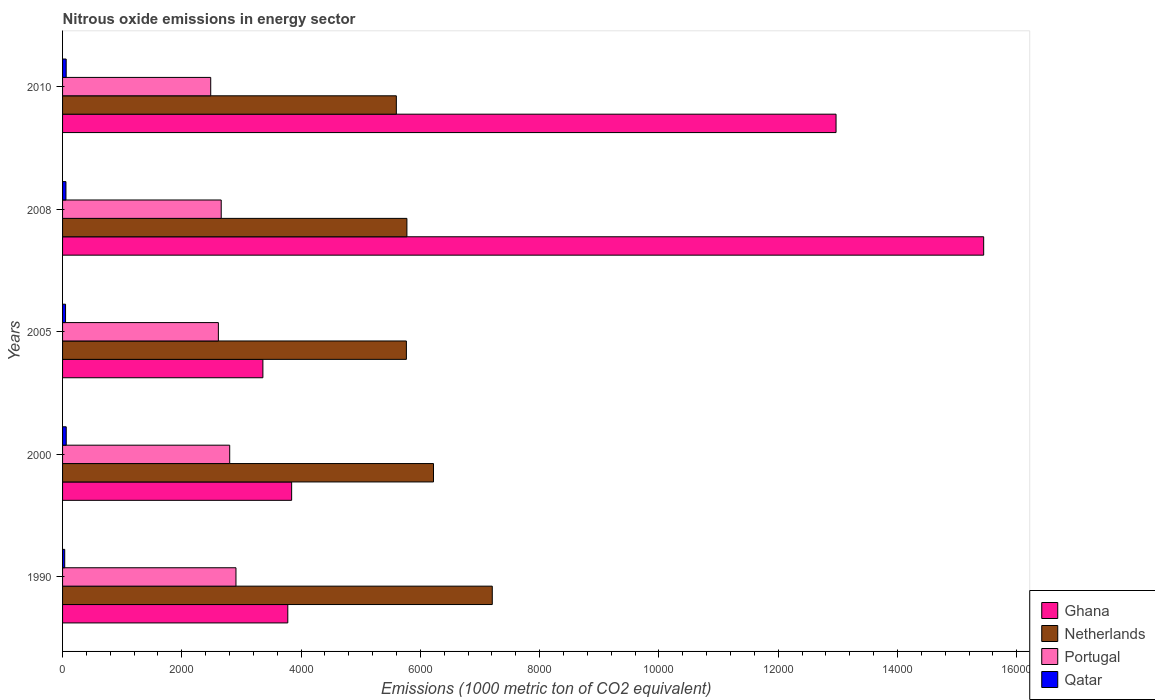How many groups of bars are there?
Make the answer very short. 5. Are the number of bars per tick equal to the number of legend labels?
Offer a very short reply. Yes. Are the number of bars on each tick of the Y-axis equal?
Provide a succinct answer. Yes. How many bars are there on the 2nd tick from the top?
Give a very brief answer. 4. What is the label of the 3rd group of bars from the top?
Make the answer very short. 2005. In how many cases, is the number of bars for a given year not equal to the number of legend labels?
Offer a terse response. 0. What is the amount of nitrous oxide emitted in Netherlands in 2005?
Ensure brevity in your answer.  5764.8. Across all years, what is the maximum amount of nitrous oxide emitted in Qatar?
Make the answer very short. 61.6. Across all years, what is the minimum amount of nitrous oxide emitted in Netherlands?
Provide a succinct answer. 5596.3. What is the total amount of nitrous oxide emitted in Portugal in the graph?
Give a very brief answer. 1.35e+04. What is the difference between the amount of nitrous oxide emitted in Qatar in 1990 and that in 2008?
Offer a terse response. -20.6. What is the difference between the amount of nitrous oxide emitted in Ghana in 2010 and the amount of nitrous oxide emitted in Netherlands in 2008?
Offer a very short reply. 7195.3. What is the average amount of nitrous oxide emitted in Netherlands per year?
Offer a terse response. 6111.84. In the year 2008, what is the difference between the amount of nitrous oxide emitted in Netherlands and amount of nitrous oxide emitted in Qatar?
Keep it short and to the point. 5717. What is the ratio of the amount of nitrous oxide emitted in Ghana in 2000 to that in 2008?
Ensure brevity in your answer.  0.25. Is the amount of nitrous oxide emitted in Ghana in 1990 less than that in 2005?
Ensure brevity in your answer.  No. Is the difference between the amount of nitrous oxide emitted in Netherlands in 1990 and 2010 greater than the difference between the amount of nitrous oxide emitted in Qatar in 1990 and 2010?
Your answer should be compact. Yes. What is the difference between the highest and the second highest amount of nitrous oxide emitted in Netherlands?
Your response must be concise. 985.5. What is the difference between the highest and the lowest amount of nitrous oxide emitted in Qatar?
Offer a terse response. 25.6. In how many years, is the amount of nitrous oxide emitted in Ghana greater than the average amount of nitrous oxide emitted in Ghana taken over all years?
Your response must be concise. 2. Is the sum of the amount of nitrous oxide emitted in Ghana in 1990 and 2005 greater than the maximum amount of nitrous oxide emitted in Portugal across all years?
Make the answer very short. Yes. Is it the case that in every year, the sum of the amount of nitrous oxide emitted in Netherlands and amount of nitrous oxide emitted in Qatar is greater than the sum of amount of nitrous oxide emitted in Ghana and amount of nitrous oxide emitted in Portugal?
Provide a short and direct response. Yes. What does the 4th bar from the top in 1990 represents?
Provide a succinct answer. Ghana. Are all the bars in the graph horizontal?
Give a very brief answer. Yes. What is the difference between two consecutive major ticks on the X-axis?
Provide a succinct answer. 2000. Are the values on the major ticks of X-axis written in scientific E-notation?
Keep it short and to the point. No. Does the graph contain any zero values?
Provide a short and direct response. No. How are the legend labels stacked?
Give a very brief answer. Vertical. What is the title of the graph?
Your answer should be very brief. Nitrous oxide emissions in energy sector. Does "Seychelles" appear as one of the legend labels in the graph?
Your answer should be compact. No. What is the label or title of the X-axis?
Your response must be concise. Emissions (1000 metric ton of CO2 equivalent). What is the label or title of the Y-axis?
Offer a very short reply. Years. What is the Emissions (1000 metric ton of CO2 equivalent) of Ghana in 1990?
Offer a very short reply. 3776.4. What is the Emissions (1000 metric ton of CO2 equivalent) of Netherlands in 1990?
Offer a very short reply. 7205. What is the Emissions (1000 metric ton of CO2 equivalent) of Portugal in 1990?
Offer a terse response. 2907.5. What is the Emissions (1000 metric ton of CO2 equivalent) in Qatar in 1990?
Ensure brevity in your answer.  36. What is the Emissions (1000 metric ton of CO2 equivalent) of Ghana in 2000?
Your answer should be compact. 3840.8. What is the Emissions (1000 metric ton of CO2 equivalent) of Netherlands in 2000?
Provide a short and direct response. 6219.5. What is the Emissions (1000 metric ton of CO2 equivalent) in Portugal in 2000?
Provide a succinct answer. 2802.4. What is the Emissions (1000 metric ton of CO2 equivalent) in Qatar in 2000?
Your answer should be compact. 61.6. What is the Emissions (1000 metric ton of CO2 equivalent) of Ghana in 2005?
Your answer should be very brief. 3358.7. What is the Emissions (1000 metric ton of CO2 equivalent) of Netherlands in 2005?
Offer a terse response. 5764.8. What is the Emissions (1000 metric ton of CO2 equivalent) of Portugal in 2005?
Provide a short and direct response. 2612.4. What is the Emissions (1000 metric ton of CO2 equivalent) in Qatar in 2005?
Make the answer very short. 49.9. What is the Emissions (1000 metric ton of CO2 equivalent) in Ghana in 2008?
Offer a terse response. 1.54e+04. What is the Emissions (1000 metric ton of CO2 equivalent) in Netherlands in 2008?
Your answer should be very brief. 5773.6. What is the Emissions (1000 metric ton of CO2 equivalent) in Portugal in 2008?
Offer a very short reply. 2660.2. What is the Emissions (1000 metric ton of CO2 equivalent) of Qatar in 2008?
Make the answer very short. 56.6. What is the Emissions (1000 metric ton of CO2 equivalent) of Ghana in 2010?
Your response must be concise. 1.30e+04. What is the Emissions (1000 metric ton of CO2 equivalent) of Netherlands in 2010?
Make the answer very short. 5596.3. What is the Emissions (1000 metric ton of CO2 equivalent) in Portugal in 2010?
Provide a succinct answer. 2484. What is the Emissions (1000 metric ton of CO2 equivalent) of Qatar in 2010?
Your answer should be very brief. 60.6. Across all years, what is the maximum Emissions (1000 metric ton of CO2 equivalent) of Ghana?
Your answer should be very brief. 1.54e+04. Across all years, what is the maximum Emissions (1000 metric ton of CO2 equivalent) of Netherlands?
Offer a terse response. 7205. Across all years, what is the maximum Emissions (1000 metric ton of CO2 equivalent) of Portugal?
Give a very brief answer. 2907.5. Across all years, what is the maximum Emissions (1000 metric ton of CO2 equivalent) in Qatar?
Your response must be concise. 61.6. Across all years, what is the minimum Emissions (1000 metric ton of CO2 equivalent) in Ghana?
Offer a very short reply. 3358.7. Across all years, what is the minimum Emissions (1000 metric ton of CO2 equivalent) of Netherlands?
Provide a short and direct response. 5596.3. Across all years, what is the minimum Emissions (1000 metric ton of CO2 equivalent) of Portugal?
Offer a very short reply. 2484. What is the total Emissions (1000 metric ton of CO2 equivalent) of Ghana in the graph?
Provide a short and direct response. 3.94e+04. What is the total Emissions (1000 metric ton of CO2 equivalent) in Netherlands in the graph?
Give a very brief answer. 3.06e+04. What is the total Emissions (1000 metric ton of CO2 equivalent) of Portugal in the graph?
Ensure brevity in your answer.  1.35e+04. What is the total Emissions (1000 metric ton of CO2 equivalent) in Qatar in the graph?
Ensure brevity in your answer.  264.7. What is the difference between the Emissions (1000 metric ton of CO2 equivalent) of Ghana in 1990 and that in 2000?
Offer a very short reply. -64.4. What is the difference between the Emissions (1000 metric ton of CO2 equivalent) of Netherlands in 1990 and that in 2000?
Your answer should be compact. 985.5. What is the difference between the Emissions (1000 metric ton of CO2 equivalent) in Portugal in 1990 and that in 2000?
Your answer should be compact. 105.1. What is the difference between the Emissions (1000 metric ton of CO2 equivalent) of Qatar in 1990 and that in 2000?
Your answer should be very brief. -25.6. What is the difference between the Emissions (1000 metric ton of CO2 equivalent) of Ghana in 1990 and that in 2005?
Provide a succinct answer. 417.7. What is the difference between the Emissions (1000 metric ton of CO2 equivalent) of Netherlands in 1990 and that in 2005?
Ensure brevity in your answer.  1440.2. What is the difference between the Emissions (1000 metric ton of CO2 equivalent) in Portugal in 1990 and that in 2005?
Offer a terse response. 295.1. What is the difference between the Emissions (1000 metric ton of CO2 equivalent) in Qatar in 1990 and that in 2005?
Provide a succinct answer. -13.9. What is the difference between the Emissions (1000 metric ton of CO2 equivalent) of Ghana in 1990 and that in 2008?
Offer a very short reply. -1.17e+04. What is the difference between the Emissions (1000 metric ton of CO2 equivalent) of Netherlands in 1990 and that in 2008?
Provide a short and direct response. 1431.4. What is the difference between the Emissions (1000 metric ton of CO2 equivalent) in Portugal in 1990 and that in 2008?
Keep it short and to the point. 247.3. What is the difference between the Emissions (1000 metric ton of CO2 equivalent) in Qatar in 1990 and that in 2008?
Provide a short and direct response. -20.6. What is the difference between the Emissions (1000 metric ton of CO2 equivalent) in Ghana in 1990 and that in 2010?
Give a very brief answer. -9192.5. What is the difference between the Emissions (1000 metric ton of CO2 equivalent) of Netherlands in 1990 and that in 2010?
Provide a succinct answer. 1608.7. What is the difference between the Emissions (1000 metric ton of CO2 equivalent) of Portugal in 1990 and that in 2010?
Provide a succinct answer. 423.5. What is the difference between the Emissions (1000 metric ton of CO2 equivalent) in Qatar in 1990 and that in 2010?
Your response must be concise. -24.6. What is the difference between the Emissions (1000 metric ton of CO2 equivalent) in Ghana in 2000 and that in 2005?
Your response must be concise. 482.1. What is the difference between the Emissions (1000 metric ton of CO2 equivalent) in Netherlands in 2000 and that in 2005?
Make the answer very short. 454.7. What is the difference between the Emissions (1000 metric ton of CO2 equivalent) in Portugal in 2000 and that in 2005?
Give a very brief answer. 190. What is the difference between the Emissions (1000 metric ton of CO2 equivalent) in Ghana in 2000 and that in 2008?
Give a very brief answer. -1.16e+04. What is the difference between the Emissions (1000 metric ton of CO2 equivalent) in Netherlands in 2000 and that in 2008?
Ensure brevity in your answer.  445.9. What is the difference between the Emissions (1000 metric ton of CO2 equivalent) in Portugal in 2000 and that in 2008?
Make the answer very short. 142.2. What is the difference between the Emissions (1000 metric ton of CO2 equivalent) in Qatar in 2000 and that in 2008?
Give a very brief answer. 5. What is the difference between the Emissions (1000 metric ton of CO2 equivalent) of Ghana in 2000 and that in 2010?
Offer a terse response. -9128.1. What is the difference between the Emissions (1000 metric ton of CO2 equivalent) in Netherlands in 2000 and that in 2010?
Your answer should be very brief. 623.2. What is the difference between the Emissions (1000 metric ton of CO2 equivalent) of Portugal in 2000 and that in 2010?
Your response must be concise. 318.4. What is the difference between the Emissions (1000 metric ton of CO2 equivalent) of Qatar in 2000 and that in 2010?
Provide a short and direct response. 1. What is the difference between the Emissions (1000 metric ton of CO2 equivalent) in Ghana in 2005 and that in 2008?
Keep it short and to the point. -1.21e+04. What is the difference between the Emissions (1000 metric ton of CO2 equivalent) in Portugal in 2005 and that in 2008?
Give a very brief answer. -47.8. What is the difference between the Emissions (1000 metric ton of CO2 equivalent) in Ghana in 2005 and that in 2010?
Your answer should be compact. -9610.2. What is the difference between the Emissions (1000 metric ton of CO2 equivalent) of Netherlands in 2005 and that in 2010?
Provide a succinct answer. 168.5. What is the difference between the Emissions (1000 metric ton of CO2 equivalent) in Portugal in 2005 and that in 2010?
Give a very brief answer. 128.4. What is the difference between the Emissions (1000 metric ton of CO2 equivalent) in Ghana in 2008 and that in 2010?
Ensure brevity in your answer.  2475.2. What is the difference between the Emissions (1000 metric ton of CO2 equivalent) of Netherlands in 2008 and that in 2010?
Your answer should be compact. 177.3. What is the difference between the Emissions (1000 metric ton of CO2 equivalent) in Portugal in 2008 and that in 2010?
Offer a terse response. 176.2. What is the difference between the Emissions (1000 metric ton of CO2 equivalent) in Qatar in 2008 and that in 2010?
Offer a very short reply. -4. What is the difference between the Emissions (1000 metric ton of CO2 equivalent) in Ghana in 1990 and the Emissions (1000 metric ton of CO2 equivalent) in Netherlands in 2000?
Offer a very short reply. -2443.1. What is the difference between the Emissions (1000 metric ton of CO2 equivalent) of Ghana in 1990 and the Emissions (1000 metric ton of CO2 equivalent) of Portugal in 2000?
Your answer should be compact. 974. What is the difference between the Emissions (1000 metric ton of CO2 equivalent) of Ghana in 1990 and the Emissions (1000 metric ton of CO2 equivalent) of Qatar in 2000?
Provide a short and direct response. 3714.8. What is the difference between the Emissions (1000 metric ton of CO2 equivalent) in Netherlands in 1990 and the Emissions (1000 metric ton of CO2 equivalent) in Portugal in 2000?
Your answer should be very brief. 4402.6. What is the difference between the Emissions (1000 metric ton of CO2 equivalent) in Netherlands in 1990 and the Emissions (1000 metric ton of CO2 equivalent) in Qatar in 2000?
Make the answer very short. 7143.4. What is the difference between the Emissions (1000 metric ton of CO2 equivalent) in Portugal in 1990 and the Emissions (1000 metric ton of CO2 equivalent) in Qatar in 2000?
Make the answer very short. 2845.9. What is the difference between the Emissions (1000 metric ton of CO2 equivalent) in Ghana in 1990 and the Emissions (1000 metric ton of CO2 equivalent) in Netherlands in 2005?
Provide a succinct answer. -1988.4. What is the difference between the Emissions (1000 metric ton of CO2 equivalent) of Ghana in 1990 and the Emissions (1000 metric ton of CO2 equivalent) of Portugal in 2005?
Your answer should be compact. 1164. What is the difference between the Emissions (1000 metric ton of CO2 equivalent) in Ghana in 1990 and the Emissions (1000 metric ton of CO2 equivalent) in Qatar in 2005?
Make the answer very short. 3726.5. What is the difference between the Emissions (1000 metric ton of CO2 equivalent) of Netherlands in 1990 and the Emissions (1000 metric ton of CO2 equivalent) of Portugal in 2005?
Your response must be concise. 4592.6. What is the difference between the Emissions (1000 metric ton of CO2 equivalent) of Netherlands in 1990 and the Emissions (1000 metric ton of CO2 equivalent) of Qatar in 2005?
Offer a very short reply. 7155.1. What is the difference between the Emissions (1000 metric ton of CO2 equivalent) of Portugal in 1990 and the Emissions (1000 metric ton of CO2 equivalent) of Qatar in 2005?
Offer a very short reply. 2857.6. What is the difference between the Emissions (1000 metric ton of CO2 equivalent) in Ghana in 1990 and the Emissions (1000 metric ton of CO2 equivalent) in Netherlands in 2008?
Ensure brevity in your answer.  -1997.2. What is the difference between the Emissions (1000 metric ton of CO2 equivalent) in Ghana in 1990 and the Emissions (1000 metric ton of CO2 equivalent) in Portugal in 2008?
Your response must be concise. 1116.2. What is the difference between the Emissions (1000 metric ton of CO2 equivalent) of Ghana in 1990 and the Emissions (1000 metric ton of CO2 equivalent) of Qatar in 2008?
Your response must be concise. 3719.8. What is the difference between the Emissions (1000 metric ton of CO2 equivalent) in Netherlands in 1990 and the Emissions (1000 metric ton of CO2 equivalent) in Portugal in 2008?
Give a very brief answer. 4544.8. What is the difference between the Emissions (1000 metric ton of CO2 equivalent) in Netherlands in 1990 and the Emissions (1000 metric ton of CO2 equivalent) in Qatar in 2008?
Provide a short and direct response. 7148.4. What is the difference between the Emissions (1000 metric ton of CO2 equivalent) of Portugal in 1990 and the Emissions (1000 metric ton of CO2 equivalent) of Qatar in 2008?
Provide a short and direct response. 2850.9. What is the difference between the Emissions (1000 metric ton of CO2 equivalent) of Ghana in 1990 and the Emissions (1000 metric ton of CO2 equivalent) of Netherlands in 2010?
Your answer should be compact. -1819.9. What is the difference between the Emissions (1000 metric ton of CO2 equivalent) in Ghana in 1990 and the Emissions (1000 metric ton of CO2 equivalent) in Portugal in 2010?
Give a very brief answer. 1292.4. What is the difference between the Emissions (1000 metric ton of CO2 equivalent) in Ghana in 1990 and the Emissions (1000 metric ton of CO2 equivalent) in Qatar in 2010?
Offer a terse response. 3715.8. What is the difference between the Emissions (1000 metric ton of CO2 equivalent) in Netherlands in 1990 and the Emissions (1000 metric ton of CO2 equivalent) in Portugal in 2010?
Ensure brevity in your answer.  4721. What is the difference between the Emissions (1000 metric ton of CO2 equivalent) in Netherlands in 1990 and the Emissions (1000 metric ton of CO2 equivalent) in Qatar in 2010?
Offer a terse response. 7144.4. What is the difference between the Emissions (1000 metric ton of CO2 equivalent) of Portugal in 1990 and the Emissions (1000 metric ton of CO2 equivalent) of Qatar in 2010?
Provide a succinct answer. 2846.9. What is the difference between the Emissions (1000 metric ton of CO2 equivalent) of Ghana in 2000 and the Emissions (1000 metric ton of CO2 equivalent) of Netherlands in 2005?
Provide a succinct answer. -1924. What is the difference between the Emissions (1000 metric ton of CO2 equivalent) in Ghana in 2000 and the Emissions (1000 metric ton of CO2 equivalent) in Portugal in 2005?
Give a very brief answer. 1228.4. What is the difference between the Emissions (1000 metric ton of CO2 equivalent) of Ghana in 2000 and the Emissions (1000 metric ton of CO2 equivalent) of Qatar in 2005?
Provide a succinct answer. 3790.9. What is the difference between the Emissions (1000 metric ton of CO2 equivalent) of Netherlands in 2000 and the Emissions (1000 metric ton of CO2 equivalent) of Portugal in 2005?
Your response must be concise. 3607.1. What is the difference between the Emissions (1000 metric ton of CO2 equivalent) in Netherlands in 2000 and the Emissions (1000 metric ton of CO2 equivalent) in Qatar in 2005?
Offer a terse response. 6169.6. What is the difference between the Emissions (1000 metric ton of CO2 equivalent) in Portugal in 2000 and the Emissions (1000 metric ton of CO2 equivalent) in Qatar in 2005?
Provide a succinct answer. 2752.5. What is the difference between the Emissions (1000 metric ton of CO2 equivalent) of Ghana in 2000 and the Emissions (1000 metric ton of CO2 equivalent) of Netherlands in 2008?
Keep it short and to the point. -1932.8. What is the difference between the Emissions (1000 metric ton of CO2 equivalent) in Ghana in 2000 and the Emissions (1000 metric ton of CO2 equivalent) in Portugal in 2008?
Offer a terse response. 1180.6. What is the difference between the Emissions (1000 metric ton of CO2 equivalent) of Ghana in 2000 and the Emissions (1000 metric ton of CO2 equivalent) of Qatar in 2008?
Provide a short and direct response. 3784.2. What is the difference between the Emissions (1000 metric ton of CO2 equivalent) in Netherlands in 2000 and the Emissions (1000 metric ton of CO2 equivalent) in Portugal in 2008?
Your answer should be compact. 3559.3. What is the difference between the Emissions (1000 metric ton of CO2 equivalent) in Netherlands in 2000 and the Emissions (1000 metric ton of CO2 equivalent) in Qatar in 2008?
Ensure brevity in your answer.  6162.9. What is the difference between the Emissions (1000 metric ton of CO2 equivalent) in Portugal in 2000 and the Emissions (1000 metric ton of CO2 equivalent) in Qatar in 2008?
Your answer should be compact. 2745.8. What is the difference between the Emissions (1000 metric ton of CO2 equivalent) of Ghana in 2000 and the Emissions (1000 metric ton of CO2 equivalent) of Netherlands in 2010?
Keep it short and to the point. -1755.5. What is the difference between the Emissions (1000 metric ton of CO2 equivalent) in Ghana in 2000 and the Emissions (1000 metric ton of CO2 equivalent) in Portugal in 2010?
Offer a very short reply. 1356.8. What is the difference between the Emissions (1000 metric ton of CO2 equivalent) in Ghana in 2000 and the Emissions (1000 metric ton of CO2 equivalent) in Qatar in 2010?
Ensure brevity in your answer.  3780.2. What is the difference between the Emissions (1000 metric ton of CO2 equivalent) in Netherlands in 2000 and the Emissions (1000 metric ton of CO2 equivalent) in Portugal in 2010?
Keep it short and to the point. 3735.5. What is the difference between the Emissions (1000 metric ton of CO2 equivalent) of Netherlands in 2000 and the Emissions (1000 metric ton of CO2 equivalent) of Qatar in 2010?
Keep it short and to the point. 6158.9. What is the difference between the Emissions (1000 metric ton of CO2 equivalent) in Portugal in 2000 and the Emissions (1000 metric ton of CO2 equivalent) in Qatar in 2010?
Your answer should be compact. 2741.8. What is the difference between the Emissions (1000 metric ton of CO2 equivalent) in Ghana in 2005 and the Emissions (1000 metric ton of CO2 equivalent) in Netherlands in 2008?
Offer a very short reply. -2414.9. What is the difference between the Emissions (1000 metric ton of CO2 equivalent) of Ghana in 2005 and the Emissions (1000 metric ton of CO2 equivalent) of Portugal in 2008?
Your response must be concise. 698.5. What is the difference between the Emissions (1000 metric ton of CO2 equivalent) in Ghana in 2005 and the Emissions (1000 metric ton of CO2 equivalent) in Qatar in 2008?
Ensure brevity in your answer.  3302.1. What is the difference between the Emissions (1000 metric ton of CO2 equivalent) in Netherlands in 2005 and the Emissions (1000 metric ton of CO2 equivalent) in Portugal in 2008?
Your answer should be compact. 3104.6. What is the difference between the Emissions (1000 metric ton of CO2 equivalent) in Netherlands in 2005 and the Emissions (1000 metric ton of CO2 equivalent) in Qatar in 2008?
Provide a succinct answer. 5708.2. What is the difference between the Emissions (1000 metric ton of CO2 equivalent) of Portugal in 2005 and the Emissions (1000 metric ton of CO2 equivalent) of Qatar in 2008?
Offer a terse response. 2555.8. What is the difference between the Emissions (1000 metric ton of CO2 equivalent) of Ghana in 2005 and the Emissions (1000 metric ton of CO2 equivalent) of Netherlands in 2010?
Offer a very short reply. -2237.6. What is the difference between the Emissions (1000 metric ton of CO2 equivalent) of Ghana in 2005 and the Emissions (1000 metric ton of CO2 equivalent) of Portugal in 2010?
Give a very brief answer. 874.7. What is the difference between the Emissions (1000 metric ton of CO2 equivalent) of Ghana in 2005 and the Emissions (1000 metric ton of CO2 equivalent) of Qatar in 2010?
Provide a short and direct response. 3298.1. What is the difference between the Emissions (1000 metric ton of CO2 equivalent) in Netherlands in 2005 and the Emissions (1000 metric ton of CO2 equivalent) in Portugal in 2010?
Offer a terse response. 3280.8. What is the difference between the Emissions (1000 metric ton of CO2 equivalent) of Netherlands in 2005 and the Emissions (1000 metric ton of CO2 equivalent) of Qatar in 2010?
Offer a terse response. 5704.2. What is the difference between the Emissions (1000 metric ton of CO2 equivalent) of Portugal in 2005 and the Emissions (1000 metric ton of CO2 equivalent) of Qatar in 2010?
Make the answer very short. 2551.8. What is the difference between the Emissions (1000 metric ton of CO2 equivalent) of Ghana in 2008 and the Emissions (1000 metric ton of CO2 equivalent) of Netherlands in 2010?
Offer a terse response. 9847.8. What is the difference between the Emissions (1000 metric ton of CO2 equivalent) of Ghana in 2008 and the Emissions (1000 metric ton of CO2 equivalent) of Portugal in 2010?
Your answer should be compact. 1.30e+04. What is the difference between the Emissions (1000 metric ton of CO2 equivalent) of Ghana in 2008 and the Emissions (1000 metric ton of CO2 equivalent) of Qatar in 2010?
Provide a short and direct response. 1.54e+04. What is the difference between the Emissions (1000 metric ton of CO2 equivalent) of Netherlands in 2008 and the Emissions (1000 metric ton of CO2 equivalent) of Portugal in 2010?
Give a very brief answer. 3289.6. What is the difference between the Emissions (1000 metric ton of CO2 equivalent) of Netherlands in 2008 and the Emissions (1000 metric ton of CO2 equivalent) of Qatar in 2010?
Give a very brief answer. 5713. What is the difference between the Emissions (1000 metric ton of CO2 equivalent) in Portugal in 2008 and the Emissions (1000 metric ton of CO2 equivalent) in Qatar in 2010?
Offer a terse response. 2599.6. What is the average Emissions (1000 metric ton of CO2 equivalent) in Ghana per year?
Your response must be concise. 7877.78. What is the average Emissions (1000 metric ton of CO2 equivalent) in Netherlands per year?
Your answer should be compact. 6111.84. What is the average Emissions (1000 metric ton of CO2 equivalent) of Portugal per year?
Provide a succinct answer. 2693.3. What is the average Emissions (1000 metric ton of CO2 equivalent) in Qatar per year?
Provide a short and direct response. 52.94. In the year 1990, what is the difference between the Emissions (1000 metric ton of CO2 equivalent) in Ghana and Emissions (1000 metric ton of CO2 equivalent) in Netherlands?
Your answer should be very brief. -3428.6. In the year 1990, what is the difference between the Emissions (1000 metric ton of CO2 equivalent) in Ghana and Emissions (1000 metric ton of CO2 equivalent) in Portugal?
Your answer should be compact. 868.9. In the year 1990, what is the difference between the Emissions (1000 metric ton of CO2 equivalent) in Ghana and Emissions (1000 metric ton of CO2 equivalent) in Qatar?
Offer a very short reply. 3740.4. In the year 1990, what is the difference between the Emissions (1000 metric ton of CO2 equivalent) in Netherlands and Emissions (1000 metric ton of CO2 equivalent) in Portugal?
Provide a succinct answer. 4297.5. In the year 1990, what is the difference between the Emissions (1000 metric ton of CO2 equivalent) in Netherlands and Emissions (1000 metric ton of CO2 equivalent) in Qatar?
Your response must be concise. 7169. In the year 1990, what is the difference between the Emissions (1000 metric ton of CO2 equivalent) in Portugal and Emissions (1000 metric ton of CO2 equivalent) in Qatar?
Provide a succinct answer. 2871.5. In the year 2000, what is the difference between the Emissions (1000 metric ton of CO2 equivalent) in Ghana and Emissions (1000 metric ton of CO2 equivalent) in Netherlands?
Your answer should be compact. -2378.7. In the year 2000, what is the difference between the Emissions (1000 metric ton of CO2 equivalent) in Ghana and Emissions (1000 metric ton of CO2 equivalent) in Portugal?
Offer a very short reply. 1038.4. In the year 2000, what is the difference between the Emissions (1000 metric ton of CO2 equivalent) in Ghana and Emissions (1000 metric ton of CO2 equivalent) in Qatar?
Offer a terse response. 3779.2. In the year 2000, what is the difference between the Emissions (1000 metric ton of CO2 equivalent) in Netherlands and Emissions (1000 metric ton of CO2 equivalent) in Portugal?
Ensure brevity in your answer.  3417.1. In the year 2000, what is the difference between the Emissions (1000 metric ton of CO2 equivalent) in Netherlands and Emissions (1000 metric ton of CO2 equivalent) in Qatar?
Your answer should be compact. 6157.9. In the year 2000, what is the difference between the Emissions (1000 metric ton of CO2 equivalent) in Portugal and Emissions (1000 metric ton of CO2 equivalent) in Qatar?
Provide a succinct answer. 2740.8. In the year 2005, what is the difference between the Emissions (1000 metric ton of CO2 equivalent) in Ghana and Emissions (1000 metric ton of CO2 equivalent) in Netherlands?
Your answer should be compact. -2406.1. In the year 2005, what is the difference between the Emissions (1000 metric ton of CO2 equivalent) of Ghana and Emissions (1000 metric ton of CO2 equivalent) of Portugal?
Keep it short and to the point. 746.3. In the year 2005, what is the difference between the Emissions (1000 metric ton of CO2 equivalent) of Ghana and Emissions (1000 metric ton of CO2 equivalent) of Qatar?
Your response must be concise. 3308.8. In the year 2005, what is the difference between the Emissions (1000 metric ton of CO2 equivalent) of Netherlands and Emissions (1000 metric ton of CO2 equivalent) of Portugal?
Make the answer very short. 3152.4. In the year 2005, what is the difference between the Emissions (1000 metric ton of CO2 equivalent) in Netherlands and Emissions (1000 metric ton of CO2 equivalent) in Qatar?
Provide a succinct answer. 5714.9. In the year 2005, what is the difference between the Emissions (1000 metric ton of CO2 equivalent) in Portugal and Emissions (1000 metric ton of CO2 equivalent) in Qatar?
Provide a short and direct response. 2562.5. In the year 2008, what is the difference between the Emissions (1000 metric ton of CO2 equivalent) of Ghana and Emissions (1000 metric ton of CO2 equivalent) of Netherlands?
Make the answer very short. 9670.5. In the year 2008, what is the difference between the Emissions (1000 metric ton of CO2 equivalent) of Ghana and Emissions (1000 metric ton of CO2 equivalent) of Portugal?
Your response must be concise. 1.28e+04. In the year 2008, what is the difference between the Emissions (1000 metric ton of CO2 equivalent) of Ghana and Emissions (1000 metric ton of CO2 equivalent) of Qatar?
Ensure brevity in your answer.  1.54e+04. In the year 2008, what is the difference between the Emissions (1000 metric ton of CO2 equivalent) in Netherlands and Emissions (1000 metric ton of CO2 equivalent) in Portugal?
Your answer should be very brief. 3113.4. In the year 2008, what is the difference between the Emissions (1000 metric ton of CO2 equivalent) of Netherlands and Emissions (1000 metric ton of CO2 equivalent) of Qatar?
Provide a succinct answer. 5717. In the year 2008, what is the difference between the Emissions (1000 metric ton of CO2 equivalent) in Portugal and Emissions (1000 metric ton of CO2 equivalent) in Qatar?
Your answer should be compact. 2603.6. In the year 2010, what is the difference between the Emissions (1000 metric ton of CO2 equivalent) in Ghana and Emissions (1000 metric ton of CO2 equivalent) in Netherlands?
Offer a terse response. 7372.6. In the year 2010, what is the difference between the Emissions (1000 metric ton of CO2 equivalent) in Ghana and Emissions (1000 metric ton of CO2 equivalent) in Portugal?
Provide a short and direct response. 1.05e+04. In the year 2010, what is the difference between the Emissions (1000 metric ton of CO2 equivalent) of Ghana and Emissions (1000 metric ton of CO2 equivalent) of Qatar?
Your response must be concise. 1.29e+04. In the year 2010, what is the difference between the Emissions (1000 metric ton of CO2 equivalent) in Netherlands and Emissions (1000 metric ton of CO2 equivalent) in Portugal?
Your answer should be very brief. 3112.3. In the year 2010, what is the difference between the Emissions (1000 metric ton of CO2 equivalent) in Netherlands and Emissions (1000 metric ton of CO2 equivalent) in Qatar?
Ensure brevity in your answer.  5535.7. In the year 2010, what is the difference between the Emissions (1000 metric ton of CO2 equivalent) of Portugal and Emissions (1000 metric ton of CO2 equivalent) of Qatar?
Your answer should be very brief. 2423.4. What is the ratio of the Emissions (1000 metric ton of CO2 equivalent) in Ghana in 1990 to that in 2000?
Provide a succinct answer. 0.98. What is the ratio of the Emissions (1000 metric ton of CO2 equivalent) in Netherlands in 1990 to that in 2000?
Give a very brief answer. 1.16. What is the ratio of the Emissions (1000 metric ton of CO2 equivalent) in Portugal in 1990 to that in 2000?
Provide a succinct answer. 1.04. What is the ratio of the Emissions (1000 metric ton of CO2 equivalent) of Qatar in 1990 to that in 2000?
Offer a very short reply. 0.58. What is the ratio of the Emissions (1000 metric ton of CO2 equivalent) of Ghana in 1990 to that in 2005?
Provide a succinct answer. 1.12. What is the ratio of the Emissions (1000 metric ton of CO2 equivalent) of Netherlands in 1990 to that in 2005?
Give a very brief answer. 1.25. What is the ratio of the Emissions (1000 metric ton of CO2 equivalent) in Portugal in 1990 to that in 2005?
Ensure brevity in your answer.  1.11. What is the ratio of the Emissions (1000 metric ton of CO2 equivalent) of Qatar in 1990 to that in 2005?
Give a very brief answer. 0.72. What is the ratio of the Emissions (1000 metric ton of CO2 equivalent) in Ghana in 1990 to that in 2008?
Keep it short and to the point. 0.24. What is the ratio of the Emissions (1000 metric ton of CO2 equivalent) in Netherlands in 1990 to that in 2008?
Give a very brief answer. 1.25. What is the ratio of the Emissions (1000 metric ton of CO2 equivalent) of Portugal in 1990 to that in 2008?
Offer a very short reply. 1.09. What is the ratio of the Emissions (1000 metric ton of CO2 equivalent) of Qatar in 1990 to that in 2008?
Offer a very short reply. 0.64. What is the ratio of the Emissions (1000 metric ton of CO2 equivalent) of Ghana in 1990 to that in 2010?
Ensure brevity in your answer.  0.29. What is the ratio of the Emissions (1000 metric ton of CO2 equivalent) of Netherlands in 1990 to that in 2010?
Keep it short and to the point. 1.29. What is the ratio of the Emissions (1000 metric ton of CO2 equivalent) of Portugal in 1990 to that in 2010?
Keep it short and to the point. 1.17. What is the ratio of the Emissions (1000 metric ton of CO2 equivalent) of Qatar in 1990 to that in 2010?
Ensure brevity in your answer.  0.59. What is the ratio of the Emissions (1000 metric ton of CO2 equivalent) of Ghana in 2000 to that in 2005?
Provide a succinct answer. 1.14. What is the ratio of the Emissions (1000 metric ton of CO2 equivalent) of Netherlands in 2000 to that in 2005?
Offer a terse response. 1.08. What is the ratio of the Emissions (1000 metric ton of CO2 equivalent) of Portugal in 2000 to that in 2005?
Offer a very short reply. 1.07. What is the ratio of the Emissions (1000 metric ton of CO2 equivalent) in Qatar in 2000 to that in 2005?
Offer a terse response. 1.23. What is the ratio of the Emissions (1000 metric ton of CO2 equivalent) in Ghana in 2000 to that in 2008?
Your answer should be very brief. 0.25. What is the ratio of the Emissions (1000 metric ton of CO2 equivalent) of Netherlands in 2000 to that in 2008?
Keep it short and to the point. 1.08. What is the ratio of the Emissions (1000 metric ton of CO2 equivalent) in Portugal in 2000 to that in 2008?
Provide a short and direct response. 1.05. What is the ratio of the Emissions (1000 metric ton of CO2 equivalent) in Qatar in 2000 to that in 2008?
Provide a succinct answer. 1.09. What is the ratio of the Emissions (1000 metric ton of CO2 equivalent) of Ghana in 2000 to that in 2010?
Provide a succinct answer. 0.3. What is the ratio of the Emissions (1000 metric ton of CO2 equivalent) in Netherlands in 2000 to that in 2010?
Provide a short and direct response. 1.11. What is the ratio of the Emissions (1000 metric ton of CO2 equivalent) of Portugal in 2000 to that in 2010?
Your answer should be very brief. 1.13. What is the ratio of the Emissions (1000 metric ton of CO2 equivalent) of Qatar in 2000 to that in 2010?
Provide a succinct answer. 1.02. What is the ratio of the Emissions (1000 metric ton of CO2 equivalent) in Ghana in 2005 to that in 2008?
Your response must be concise. 0.22. What is the ratio of the Emissions (1000 metric ton of CO2 equivalent) in Netherlands in 2005 to that in 2008?
Make the answer very short. 1. What is the ratio of the Emissions (1000 metric ton of CO2 equivalent) of Qatar in 2005 to that in 2008?
Ensure brevity in your answer.  0.88. What is the ratio of the Emissions (1000 metric ton of CO2 equivalent) in Ghana in 2005 to that in 2010?
Provide a short and direct response. 0.26. What is the ratio of the Emissions (1000 metric ton of CO2 equivalent) in Netherlands in 2005 to that in 2010?
Keep it short and to the point. 1.03. What is the ratio of the Emissions (1000 metric ton of CO2 equivalent) in Portugal in 2005 to that in 2010?
Give a very brief answer. 1.05. What is the ratio of the Emissions (1000 metric ton of CO2 equivalent) in Qatar in 2005 to that in 2010?
Provide a succinct answer. 0.82. What is the ratio of the Emissions (1000 metric ton of CO2 equivalent) of Ghana in 2008 to that in 2010?
Your answer should be compact. 1.19. What is the ratio of the Emissions (1000 metric ton of CO2 equivalent) of Netherlands in 2008 to that in 2010?
Give a very brief answer. 1.03. What is the ratio of the Emissions (1000 metric ton of CO2 equivalent) in Portugal in 2008 to that in 2010?
Offer a very short reply. 1.07. What is the ratio of the Emissions (1000 metric ton of CO2 equivalent) in Qatar in 2008 to that in 2010?
Give a very brief answer. 0.93. What is the difference between the highest and the second highest Emissions (1000 metric ton of CO2 equivalent) of Ghana?
Offer a very short reply. 2475.2. What is the difference between the highest and the second highest Emissions (1000 metric ton of CO2 equivalent) in Netherlands?
Your response must be concise. 985.5. What is the difference between the highest and the second highest Emissions (1000 metric ton of CO2 equivalent) of Portugal?
Provide a short and direct response. 105.1. What is the difference between the highest and the lowest Emissions (1000 metric ton of CO2 equivalent) in Ghana?
Provide a succinct answer. 1.21e+04. What is the difference between the highest and the lowest Emissions (1000 metric ton of CO2 equivalent) in Netherlands?
Provide a succinct answer. 1608.7. What is the difference between the highest and the lowest Emissions (1000 metric ton of CO2 equivalent) of Portugal?
Your response must be concise. 423.5. What is the difference between the highest and the lowest Emissions (1000 metric ton of CO2 equivalent) of Qatar?
Make the answer very short. 25.6. 